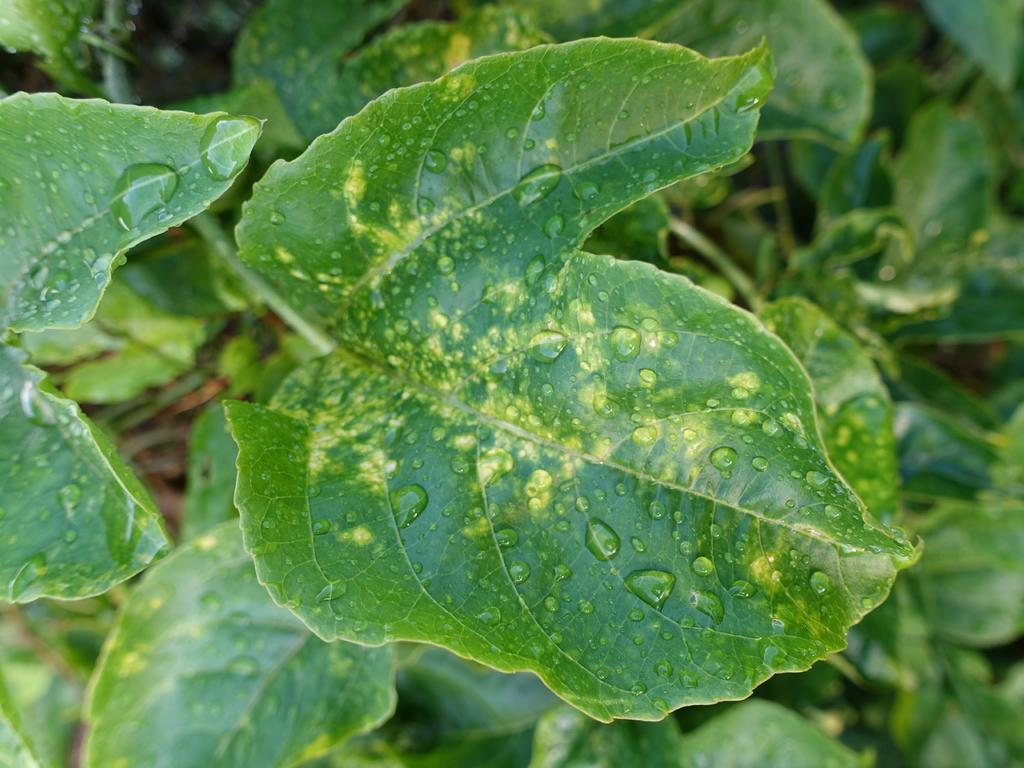What is present in the picture? There is a plant in the picture. Can you describe the plant? The plant has many leaves. Are there any notable features on the leaves? Yes, there are water droplets on one of the leaves. What type of sheet is covering the plant in the image? There is no sheet covering the plant in the image; it is not mentioned in the provided facts. 